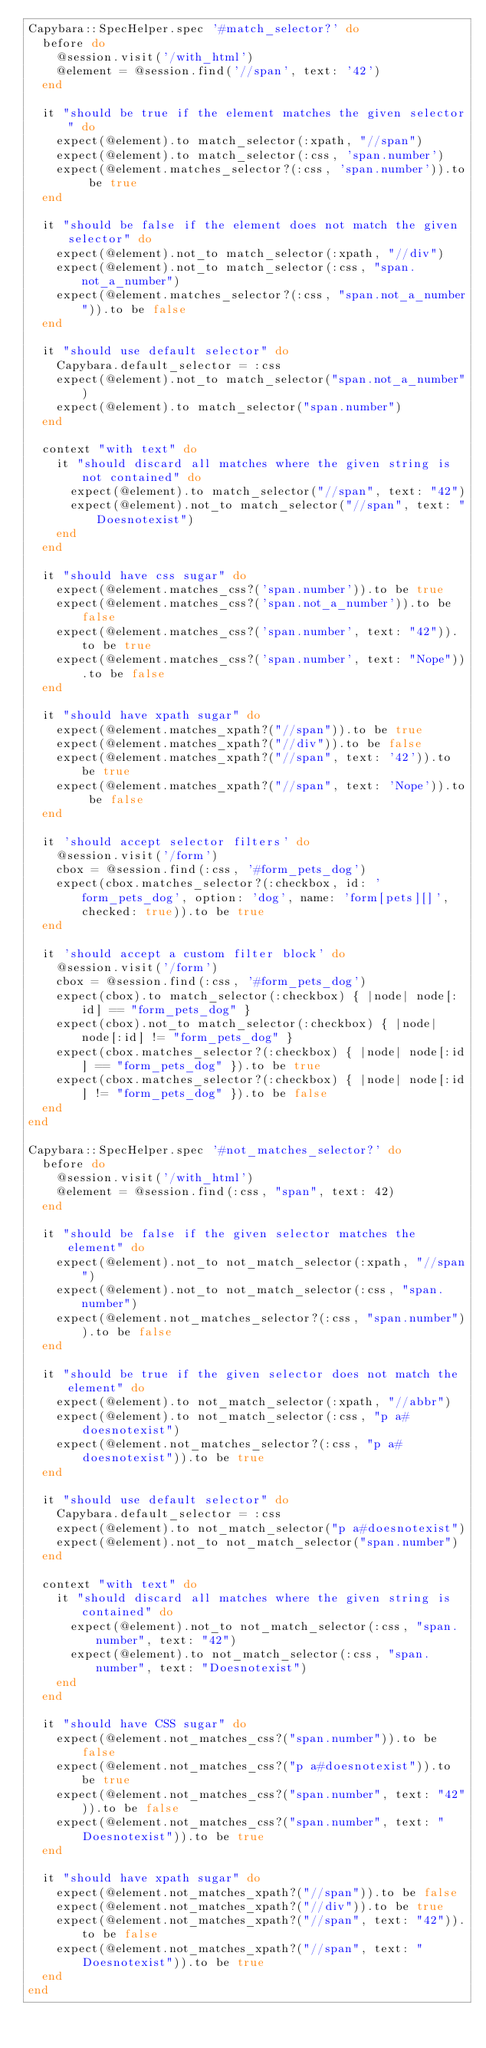<code> <loc_0><loc_0><loc_500><loc_500><_Ruby_>Capybara::SpecHelper.spec '#match_selector?' do
  before do
    @session.visit('/with_html')
    @element = @session.find('//span', text: '42')
  end

  it "should be true if the element matches the given selector" do
    expect(@element).to match_selector(:xpath, "//span")
    expect(@element).to match_selector(:css, 'span.number')
    expect(@element.matches_selector?(:css, 'span.number')).to be true
  end

  it "should be false if the element does not match the given selector" do
    expect(@element).not_to match_selector(:xpath, "//div")
    expect(@element).not_to match_selector(:css, "span.not_a_number")
    expect(@element.matches_selector?(:css, "span.not_a_number")).to be false
  end

  it "should use default selector" do
    Capybara.default_selector = :css
    expect(@element).not_to match_selector("span.not_a_number")
    expect(@element).to match_selector("span.number")
  end

  context "with text" do
    it "should discard all matches where the given string is not contained" do
      expect(@element).to match_selector("//span", text: "42")
      expect(@element).not_to match_selector("//span", text: "Doesnotexist")
    end
  end

  it "should have css sugar" do
    expect(@element.matches_css?('span.number')).to be true
    expect(@element.matches_css?('span.not_a_number')).to be false
    expect(@element.matches_css?('span.number', text: "42")).to be true
    expect(@element.matches_css?('span.number', text: "Nope")).to be false
  end

  it "should have xpath sugar" do
    expect(@element.matches_xpath?("//span")).to be true
    expect(@element.matches_xpath?("//div")).to be false
    expect(@element.matches_xpath?("//span", text: '42')).to be true
    expect(@element.matches_xpath?("//span", text: 'Nope')).to be false
  end

  it 'should accept selector filters' do
    @session.visit('/form')
    cbox = @session.find(:css, '#form_pets_dog')
    expect(cbox.matches_selector?(:checkbox, id: 'form_pets_dog', option: 'dog', name: 'form[pets][]', checked: true)).to be true
  end

  it 'should accept a custom filter block' do
    @session.visit('/form')
    cbox = @session.find(:css, '#form_pets_dog')
    expect(cbox).to match_selector(:checkbox) { |node| node[:id] == "form_pets_dog" }
    expect(cbox).not_to match_selector(:checkbox) { |node| node[:id] != "form_pets_dog" }
    expect(cbox.matches_selector?(:checkbox) { |node| node[:id] == "form_pets_dog" }).to be true
    expect(cbox.matches_selector?(:checkbox) { |node| node[:id] != "form_pets_dog" }).to be false
  end
end

Capybara::SpecHelper.spec '#not_matches_selector?' do
  before do
    @session.visit('/with_html')
    @element = @session.find(:css, "span", text: 42)
  end

  it "should be false if the given selector matches the element" do
    expect(@element).not_to not_match_selector(:xpath, "//span")
    expect(@element).not_to not_match_selector(:css, "span.number")
    expect(@element.not_matches_selector?(:css, "span.number")).to be false
  end

  it "should be true if the given selector does not match the element" do
    expect(@element).to not_match_selector(:xpath, "//abbr")
    expect(@element).to not_match_selector(:css, "p a#doesnotexist")
    expect(@element.not_matches_selector?(:css, "p a#doesnotexist")).to be true
  end

  it "should use default selector" do
    Capybara.default_selector = :css
    expect(@element).to not_match_selector("p a#doesnotexist")
    expect(@element).not_to not_match_selector("span.number")
  end

  context "with text" do
    it "should discard all matches where the given string is contained" do
      expect(@element).not_to not_match_selector(:css, "span.number", text: "42")
      expect(@element).to not_match_selector(:css, "span.number", text: "Doesnotexist")
    end
  end

  it "should have CSS sugar" do
    expect(@element.not_matches_css?("span.number")).to be false
    expect(@element.not_matches_css?("p a#doesnotexist")).to be true
    expect(@element.not_matches_css?("span.number", text: "42")).to be false
    expect(@element.not_matches_css?("span.number", text: "Doesnotexist")).to be true
  end

  it "should have xpath sugar" do
    expect(@element.not_matches_xpath?("//span")).to be false
    expect(@element.not_matches_xpath?("//div")).to be true
    expect(@element.not_matches_xpath?("//span", text: "42")).to be false
    expect(@element.not_matches_xpath?("//span", text: "Doesnotexist")).to be true
  end
end
</code> 